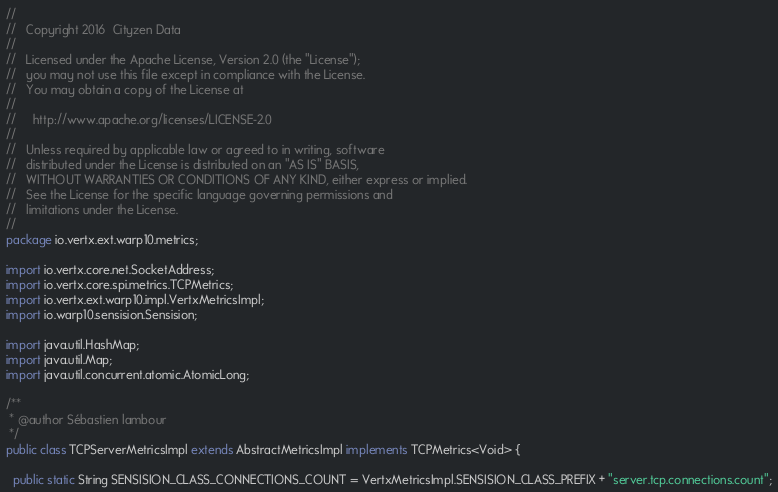Convert code to text. <code><loc_0><loc_0><loc_500><loc_500><_Java_>//
//   Copyright 2016  Cityzen Data
//
//   Licensed under the Apache License, Version 2.0 (the "License");
//   you may not use this file except in compliance with the License.
//   You may obtain a copy of the License at
//
//     http://www.apache.org/licenses/LICENSE-2.0
//
//   Unless required by applicable law or agreed to in writing, software
//   distributed under the License is distributed on an "AS IS" BASIS,
//   WITHOUT WARRANTIES OR CONDITIONS OF ANY KIND, either express or implied.
//   See the License for the specific language governing permissions and
//   limitations under the License.
//
package io.vertx.ext.warp10.metrics;

import io.vertx.core.net.SocketAddress;
import io.vertx.core.spi.metrics.TCPMetrics;
import io.vertx.ext.warp10.impl.VertxMetricsImpl;
import io.warp10.sensision.Sensision;

import java.util.HashMap;
import java.util.Map;
import java.util.concurrent.atomic.AtomicLong;

/**
 * @author Sébastien lambour
 */
public class TCPServerMetricsImpl extends AbstractMetricsImpl implements TCPMetrics<Void> {

  public static String SENSISION_CLASS_CONNECTIONS_COUNT = VertxMetricsImpl.SENSISION_CLASS_PREFIX + "server.tcp.connections.count";</code> 